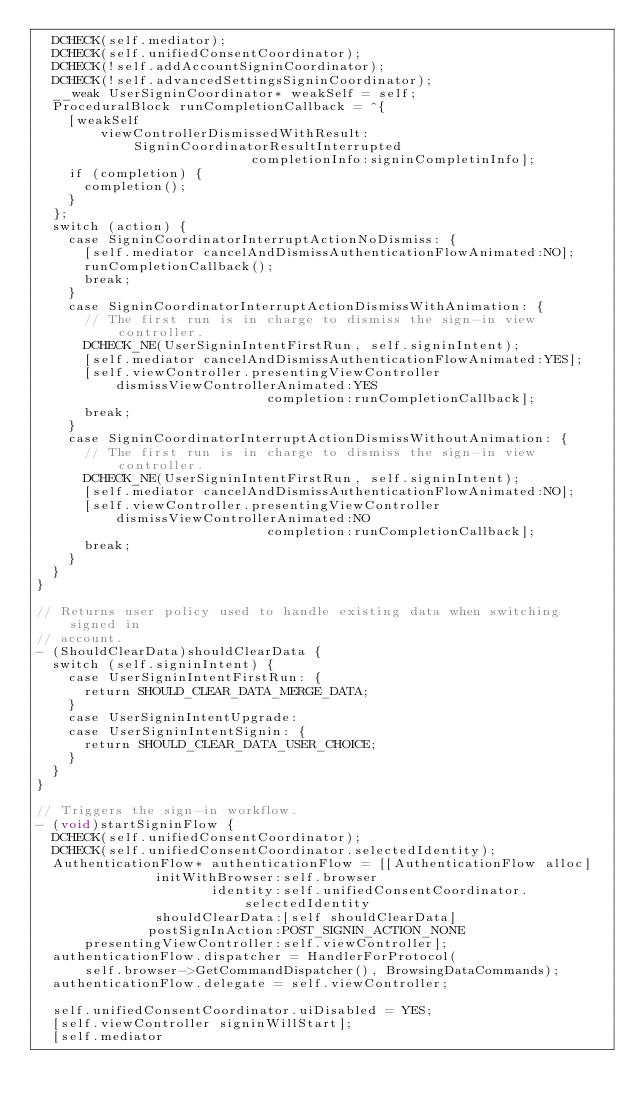<code> <loc_0><loc_0><loc_500><loc_500><_ObjectiveC_>  DCHECK(self.mediator);
  DCHECK(self.unifiedConsentCoordinator);
  DCHECK(!self.addAccountSigninCoordinator);
  DCHECK(!self.advancedSettingsSigninCoordinator);
  __weak UserSigninCoordinator* weakSelf = self;
  ProceduralBlock runCompletionCallback = ^{
    [weakSelf
        viewControllerDismissedWithResult:SigninCoordinatorResultInterrupted
                           completionInfo:signinCompletinInfo];
    if (completion) {
      completion();
    }
  };
  switch (action) {
    case SigninCoordinatorInterruptActionNoDismiss: {
      [self.mediator cancelAndDismissAuthenticationFlowAnimated:NO];
      runCompletionCallback();
      break;
    }
    case SigninCoordinatorInterruptActionDismissWithAnimation: {
      // The first run is in charge to dismiss the sign-in view controller.
      DCHECK_NE(UserSigninIntentFirstRun, self.signinIntent);
      [self.mediator cancelAndDismissAuthenticationFlowAnimated:YES];
      [self.viewController.presentingViewController
          dismissViewControllerAnimated:YES
                             completion:runCompletionCallback];
      break;
    }
    case SigninCoordinatorInterruptActionDismissWithoutAnimation: {
      // The first run is in charge to dismiss the sign-in view controller.
      DCHECK_NE(UserSigninIntentFirstRun, self.signinIntent);
      [self.mediator cancelAndDismissAuthenticationFlowAnimated:NO];
      [self.viewController.presentingViewController
          dismissViewControllerAnimated:NO
                             completion:runCompletionCallback];
      break;
    }
  }
}

// Returns user policy used to handle existing data when switching signed in
// account.
- (ShouldClearData)shouldClearData {
  switch (self.signinIntent) {
    case UserSigninIntentFirstRun: {
      return SHOULD_CLEAR_DATA_MERGE_DATA;
    }
    case UserSigninIntentUpgrade:
    case UserSigninIntentSignin: {
      return SHOULD_CLEAR_DATA_USER_CHOICE;
    }
  }
}

// Triggers the sign-in workflow.
- (void)startSigninFlow {
  DCHECK(self.unifiedConsentCoordinator);
  DCHECK(self.unifiedConsentCoordinator.selectedIdentity);
  AuthenticationFlow* authenticationFlow = [[AuthenticationFlow alloc]
               initWithBrowser:self.browser
                      identity:self.unifiedConsentCoordinator.selectedIdentity
               shouldClearData:[self shouldClearData]
              postSignInAction:POST_SIGNIN_ACTION_NONE
      presentingViewController:self.viewController];
  authenticationFlow.dispatcher = HandlerForProtocol(
      self.browser->GetCommandDispatcher(), BrowsingDataCommands);
  authenticationFlow.delegate = self.viewController;

  self.unifiedConsentCoordinator.uiDisabled = YES;
  [self.viewController signinWillStart];
  [self.mediator</code> 